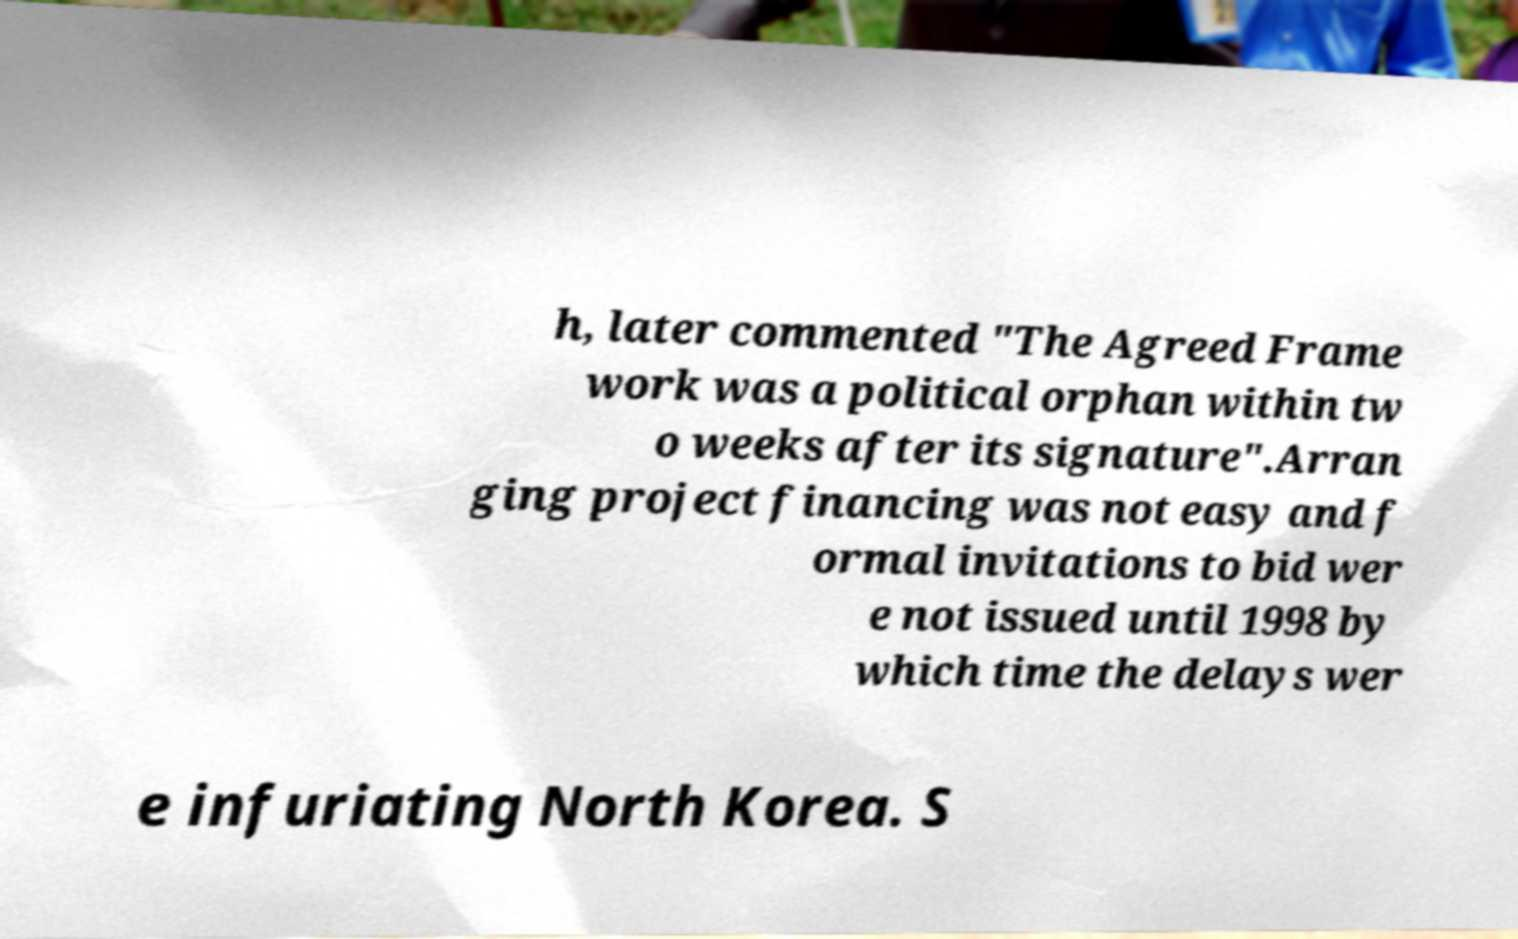Can you accurately transcribe the text from the provided image for me? h, later commented "The Agreed Frame work was a political orphan within tw o weeks after its signature".Arran ging project financing was not easy and f ormal invitations to bid wer e not issued until 1998 by which time the delays wer e infuriating North Korea. S 